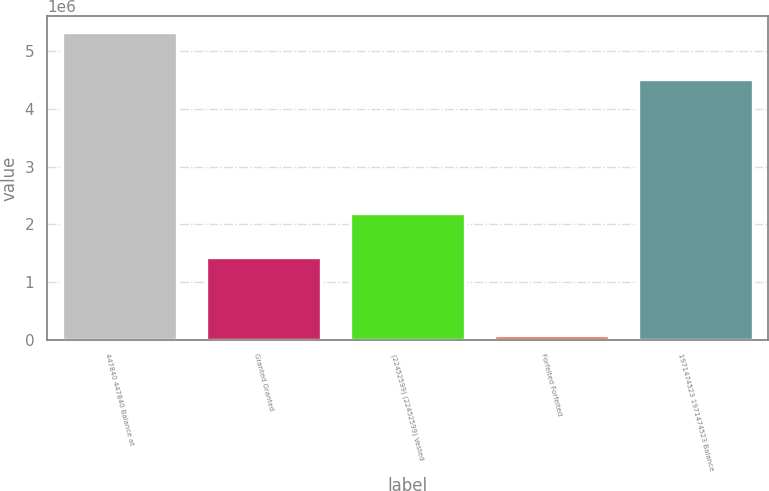Convert chart to OTSL. <chart><loc_0><loc_0><loc_500><loc_500><bar_chart><fcel>447840 447840 Balance at<fcel>Granted Granted<fcel>(22452599) (22452599) Vested<fcel>Forfeited Forfeited<fcel>1971474523 1971474523 Balance<nl><fcel>5.33286e+06<fcel>1.44188e+06<fcel>2.18792e+06<fcel>74910<fcel>4.51191e+06<nl></chart> 